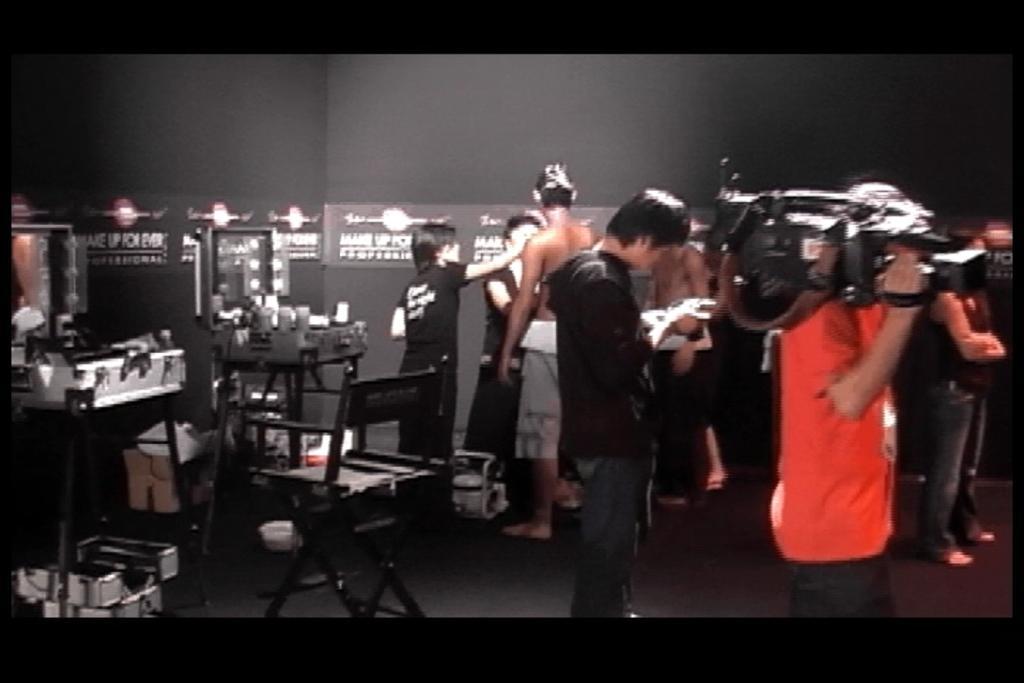How would you summarize this image in a sentence or two? In this picture there is a person wearing orange T-shirt is standing and holding a camera in the right corner and there are few persons beside him and there are two stands which has two suit cases placed on it which has a mirror and some other objects in it and there is a chair in front of it and there is something written on the wall in the background. 